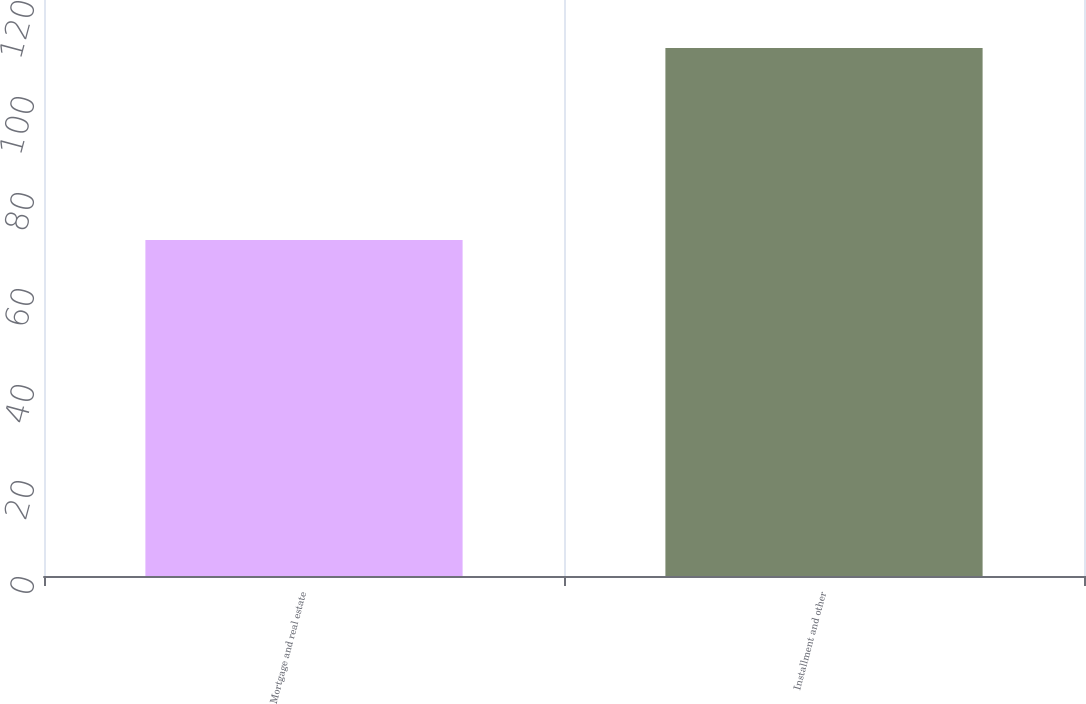Convert chart to OTSL. <chart><loc_0><loc_0><loc_500><loc_500><bar_chart><fcel>Mortgage and real estate<fcel>Installment and other<nl><fcel>70<fcel>110<nl></chart> 